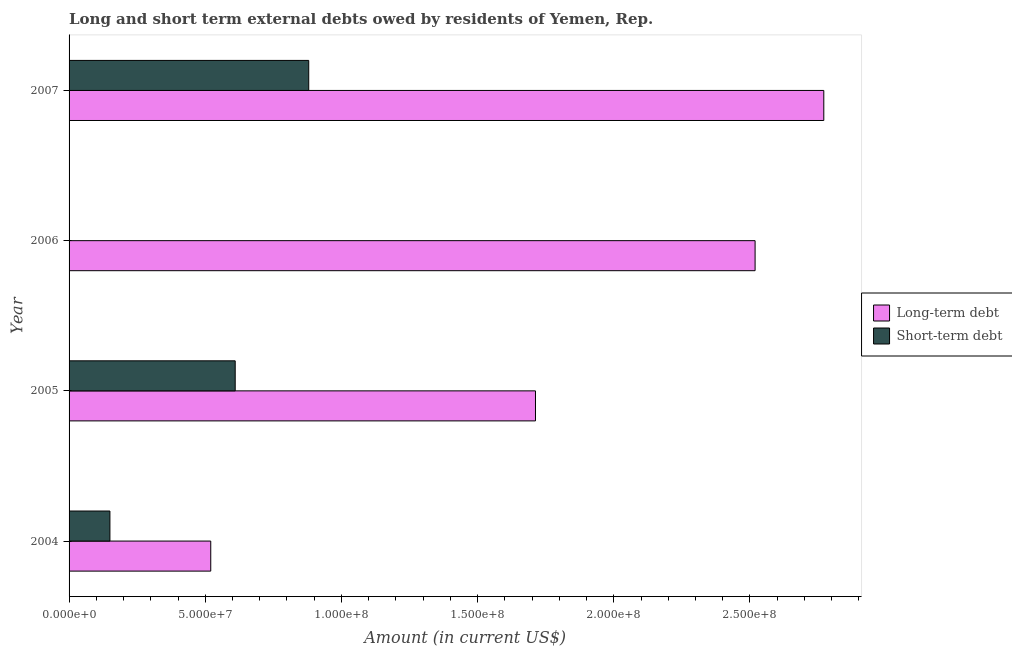Are the number of bars on each tick of the Y-axis equal?
Make the answer very short. No. How many bars are there on the 4th tick from the top?
Your response must be concise. 2. Across all years, what is the maximum long-term debts owed by residents?
Give a very brief answer. 2.77e+08. Across all years, what is the minimum long-term debts owed by residents?
Your response must be concise. 5.20e+07. What is the total short-term debts owed by residents in the graph?
Keep it short and to the point. 1.64e+08. What is the difference between the long-term debts owed by residents in 2005 and that in 2007?
Your answer should be compact. -1.06e+08. What is the difference between the short-term debts owed by residents in 2007 and the long-term debts owed by residents in 2006?
Keep it short and to the point. -1.64e+08. What is the average long-term debts owed by residents per year?
Make the answer very short. 1.88e+08. In the year 2007, what is the difference between the short-term debts owed by residents and long-term debts owed by residents?
Offer a very short reply. -1.89e+08. In how many years, is the long-term debts owed by residents greater than 50000000 US$?
Offer a terse response. 4. What is the ratio of the long-term debts owed by residents in 2004 to that in 2006?
Give a very brief answer. 0.21. What is the difference between the highest and the second highest short-term debts owed by residents?
Provide a short and direct response. 2.70e+07. What is the difference between the highest and the lowest long-term debts owed by residents?
Your answer should be very brief. 2.25e+08. In how many years, is the long-term debts owed by residents greater than the average long-term debts owed by residents taken over all years?
Your response must be concise. 2. Are all the bars in the graph horizontal?
Give a very brief answer. Yes. What is the difference between two consecutive major ticks on the X-axis?
Make the answer very short. 5.00e+07. Does the graph contain any zero values?
Provide a short and direct response. Yes. Where does the legend appear in the graph?
Your response must be concise. Center right. What is the title of the graph?
Offer a very short reply. Long and short term external debts owed by residents of Yemen, Rep. What is the Amount (in current US$) of Long-term debt in 2004?
Offer a very short reply. 5.20e+07. What is the Amount (in current US$) of Short-term debt in 2004?
Give a very brief answer. 1.50e+07. What is the Amount (in current US$) of Long-term debt in 2005?
Offer a terse response. 1.71e+08. What is the Amount (in current US$) in Short-term debt in 2005?
Offer a very short reply. 6.10e+07. What is the Amount (in current US$) of Long-term debt in 2006?
Give a very brief answer. 2.52e+08. What is the Amount (in current US$) of Long-term debt in 2007?
Offer a terse response. 2.77e+08. What is the Amount (in current US$) in Short-term debt in 2007?
Offer a terse response. 8.80e+07. Across all years, what is the maximum Amount (in current US$) in Long-term debt?
Your response must be concise. 2.77e+08. Across all years, what is the maximum Amount (in current US$) of Short-term debt?
Keep it short and to the point. 8.80e+07. Across all years, what is the minimum Amount (in current US$) of Long-term debt?
Offer a very short reply. 5.20e+07. Across all years, what is the minimum Amount (in current US$) in Short-term debt?
Keep it short and to the point. 0. What is the total Amount (in current US$) in Long-term debt in the graph?
Offer a very short reply. 7.52e+08. What is the total Amount (in current US$) in Short-term debt in the graph?
Keep it short and to the point. 1.64e+08. What is the difference between the Amount (in current US$) in Long-term debt in 2004 and that in 2005?
Offer a terse response. -1.19e+08. What is the difference between the Amount (in current US$) in Short-term debt in 2004 and that in 2005?
Provide a short and direct response. -4.60e+07. What is the difference between the Amount (in current US$) in Long-term debt in 2004 and that in 2006?
Give a very brief answer. -2.00e+08. What is the difference between the Amount (in current US$) in Long-term debt in 2004 and that in 2007?
Ensure brevity in your answer.  -2.25e+08. What is the difference between the Amount (in current US$) of Short-term debt in 2004 and that in 2007?
Provide a short and direct response. -7.30e+07. What is the difference between the Amount (in current US$) of Long-term debt in 2005 and that in 2006?
Provide a short and direct response. -8.06e+07. What is the difference between the Amount (in current US$) in Long-term debt in 2005 and that in 2007?
Offer a very short reply. -1.06e+08. What is the difference between the Amount (in current US$) of Short-term debt in 2005 and that in 2007?
Provide a succinct answer. -2.70e+07. What is the difference between the Amount (in current US$) of Long-term debt in 2006 and that in 2007?
Give a very brief answer. -2.52e+07. What is the difference between the Amount (in current US$) of Long-term debt in 2004 and the Amount (in current US$) of Short-term debt in 2005?
Your answer should be very brief. -8.98e+06. What is the difference between the Amount (in current US$) in Long-term debt in 2004 and the Amount (in current US$) in Short-term debt in 2007?
Your response must be concise. -3.60e+07. What is the difference between the Amount (in current US$) in Long-term debt in 2005 and the Amount (in current US$) in Short-term debt in 2007?
Your answer should be compact. 8.33e+07. What is the difference between the Amount (in current US$) of Long-term debt in 2006 and the Amount (in current US$) of Short-term debt in 2007?
Your answer should be compact. 1.64e+08. What is the average Amount (in current US$) of Long-term debt per year?
Give a very brief answer. 1.88e+08. What is the average Amount (in current US$) in Short-term debt per year?
Provide a short and direct response. 4.10e+07. In the year 2004, what is the difference between the Amount (in current US$) in Long-term debt and Amount (in current US$) in Short-term debt?
Ensure brevity in your answer.  3.70e+07. In the year 2005, what is the difference between the Amount (in current US$) in Long-term debt and Amount (in current US$) in Short-term debt?
Offer a very short reply. 1.10e+08. In the year 2007, what is the difference between the Amount (in current US$) of Long-term debt and Amount (in current US$) of Short-term debt?
Your response must be concise. 1.89e+08. What is the ratio of the Amount (in current US$) of Long-term debt in 2004 to that in 2005?
Offer a very short reply. 0.3. What is the ratio of the Amount (in current US$) in Short-term debt in 2004 to that in 2005?
Your answer should be very brief. 0.25. What is the ratio of the Amount (in current US$) of Long-term debt in 2004 to that in 2006?
Provide a succinct answer. 0.21. What is the ratio of the Amount (in current US$) in Long-term debt in 2004 to that in 2007?
Offer a very short reply. 0.19. What is the ratio of the Amount (in current US$) of Short-term debt in 2004 to that in 2007?
Keep it short and to the point. 0.17. What is the ratio of the Amount (in current US$) of Long-term debt in 2005 to that in 2006?
Ensure brevity in your answer.  0.68. What is the ratio of the Amount (in current US$) of Long-term debt in 2005 to that in 2007?
Provide a short and direct response. 0.62. What is the ratio of the Amount (in current US$) in Short-term debt in 2005 to that in 2007?
Provide a short and direct response. 0.69. What is the ratio of the Amount (in current US$) in Long-term debt in 2006 to that in 2007?
Offer a very short reply. 0.91. What is the difference between the highest and the second highest Amount (in current US$) of Long-term debt?
Provide a succinct answer. 2.52e+07. What is the difference between the highest and the second highest Amount (in current US$) of Short-term debt?
Provide a succinct answer. 2.70e+07. What is the difference between the highest and the lowest Amount (in current US$) in Long-term debt?
Keep it short and to the point. 2.25e+08. What is the difference between the highest and the lowest Amount (in current US$) in Short-term debt?
Ensure brevity in your answer.  8.80e+07. 